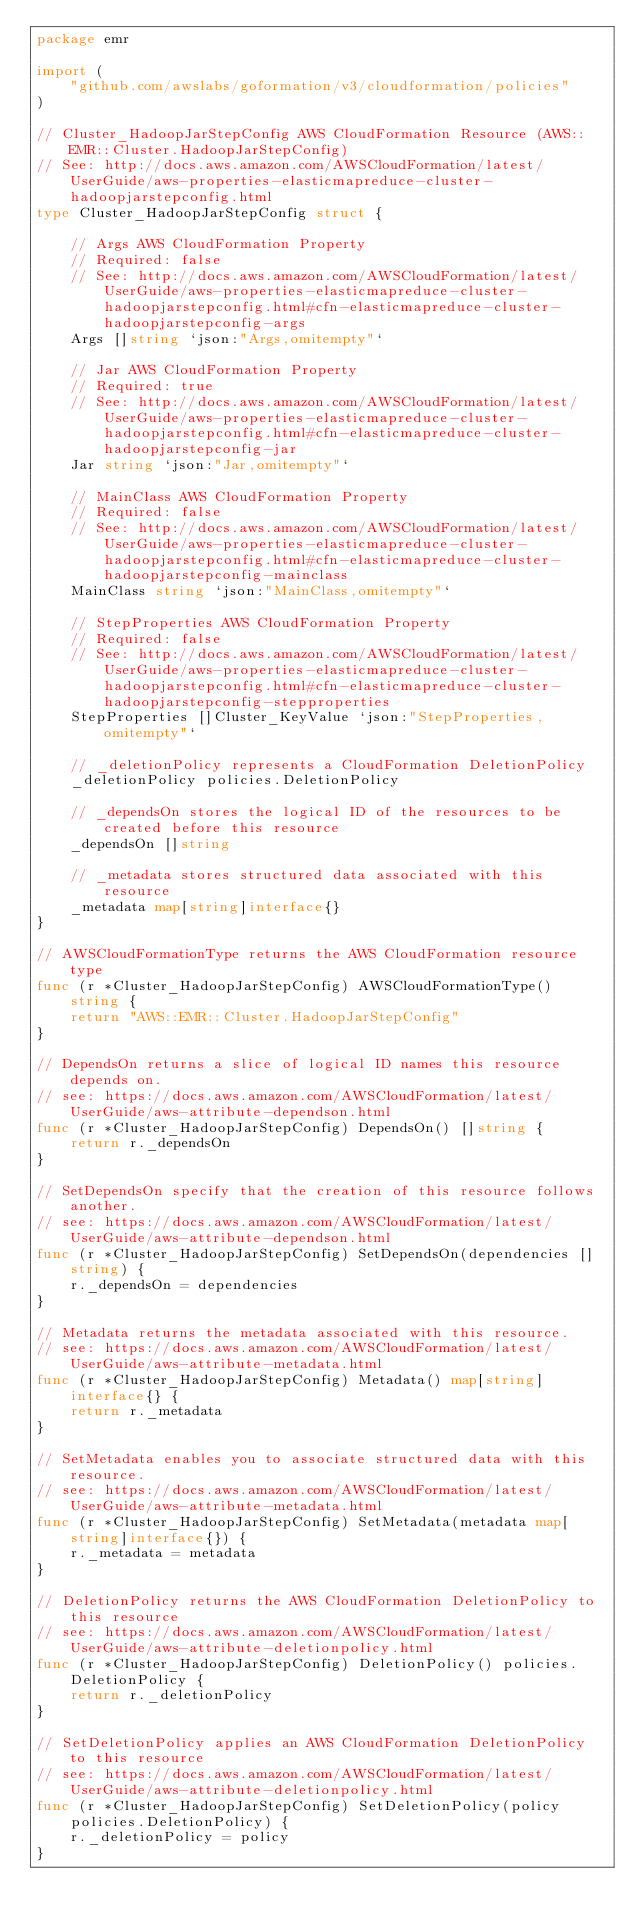<code> <loc_0><loc_0><loc_500><loc_500><_Go_>package emr

import (
	"github.com/awslabs/goformation/v3/cloudformation/policies"
)

// Cluster_HadoopJarStepConfig AWS CloudFormation Resource (AWS::EMR::Cluster.HadoopJarStepConfig)
// See: http://docs.aws.amazon.com/AWSCloudFormation/latest/UserGuide/aws-properties-elasticmapreduce-cluster-hadoopjarstepconfig.html
type Cluster_HadoopJarStepConfig struct {

	// Args AWS CloudFormation Property
	// Required: false
	// See: http://docs.aws.amazon.com/AWSCloudFormation/latest/UserGuide/aws-properties-elasticmapreduce-cluster-hadoopjarstepconfig.html#cfn-elasticmapreduce-cluster-hadoopjarstepconfig-args
	Args []string `json:"Args,omitempty"`

	// Jar AWS CloudFormation Property
	// Required: true
	// See: http://docs.aws.amazon.com/AWSCloudFormation/latest/UserGuide/aws-properties-elasticmapreduce-cluster-hadoopjarstepconfig.html#cfn-elasticmapreduce-cluster-hadoopjarstepconfig-jar
	Jar string `json:"Jar,omitempty"`

	// MainClass AWS CloudFormation Property
	// Required: false
	// See: http://docs.aws.amazon.com/AWSCloudFormation/latest/UserGuide/aws-properties-elasticmapreduce-cluster-hadoopjarstepconfig.html#cfn-elasticmapreduce-cluster-hadoopjarstepconfig-mainclass
	MainClass string `json:"MainClass,omitempty"`

	// StepProperties AWS CloudFormation Property
	// Required: false
	// See: http://docs.aws.amazon.com/AWSCloudFormation/latest/UserGuide/aws-properties-elasticmapreduce-cluster-hadoopjarstepconfig.html#cfn-elasticmapreduce-cluster-hadoopjarstepconfig-stepproperties
	StepProperties []Cluster_KeyValue `json:"StepProperties,omitempty"`

	// _deletionPolicy represents a CloudFormation DeletionPolicy
	_deletionPolicy policies.DeletionPolicy

	// _dependsOn stores the logical ID of the resources to be created before this resource
	_dependsOn []string

	// _metadata stores structured data associated with this resource
	_metadata map[string]interface{}
}

// AWSCloudFormationType returns the AWS CloudFormation resource type
func (r *Cluster_HadoopJarStepConfig) AWSCloudFormationType() string {
	return "AWS::EMR::Cluster.HadoopJarStepConfig"
}

// DependsOn returns a slice of logical ID names this resource depends on.
// see: https://docs.aws.amazon.com/AWSCloudFormation/latest/UserGuide/aws-attribute-dependson.html
func (r *Cluster_HadoopJarStepConfig) DependsOn() []string {
	return r._dependsOn
}

// SetDependsOn specify that the creation of this resource follows another.
// see: https://docs.aws.amazon.com/AWSCloudFormation/latest/UserGuide/aws-attribute-dependson.html
func (r *Cluster_HadoopJarStepConfig) SetDependsOn(dependencies []string) {
	r._dependsOn = dependencies
}

// Metadata returns the metadata associated with this resource.
// see: https://docs.aws.amazon.com/AWSCloudFormation/latest/UserGuide/aws-attribute-metadata.html
func (r *Cluster_HadoopJarStepConfig) Metadata() map[string]interface{} {
	return r._metadata
}

// SetMetadata enables you to associate structured data with this resource.
// see: https://docs.aws.amazon.com/AWSCloudFormation/latest/UserGuide/aws-attribute-metadata.html
func (r *Cluster_HadoopJarStepConfig) SetMetadata(metadata map[string]interface{}) {
	r._metadata = metadata
}

// DeletionPolicy returns the AWS CloudFormation DeletionPolicy to this resource
// see: https://docs.aws.amazon.com/AWSCloudFormation/latest/UserGuide/aws-attribute-deletionpolicy.html
func (r *Cluster_HadoopJarStepConfig) DeletionPolicy() policies.DeletionPolicy {
	return r._deletionPolicy
}

// SetDeletionPolicy applies an AWS CloudFormation DeletionPolicy to this resource
// see: https://docs.aws.amazon.com/AWSCloudFormation/latest/UserGuide/aws-attribute-deletionpolicy.html
func (r *Cluster_HadoopJarStepConfig) SetDeletionPolicy(policy policies.DeletionPolicy) {
	r._deletionPolicy = policy
}
</code> 